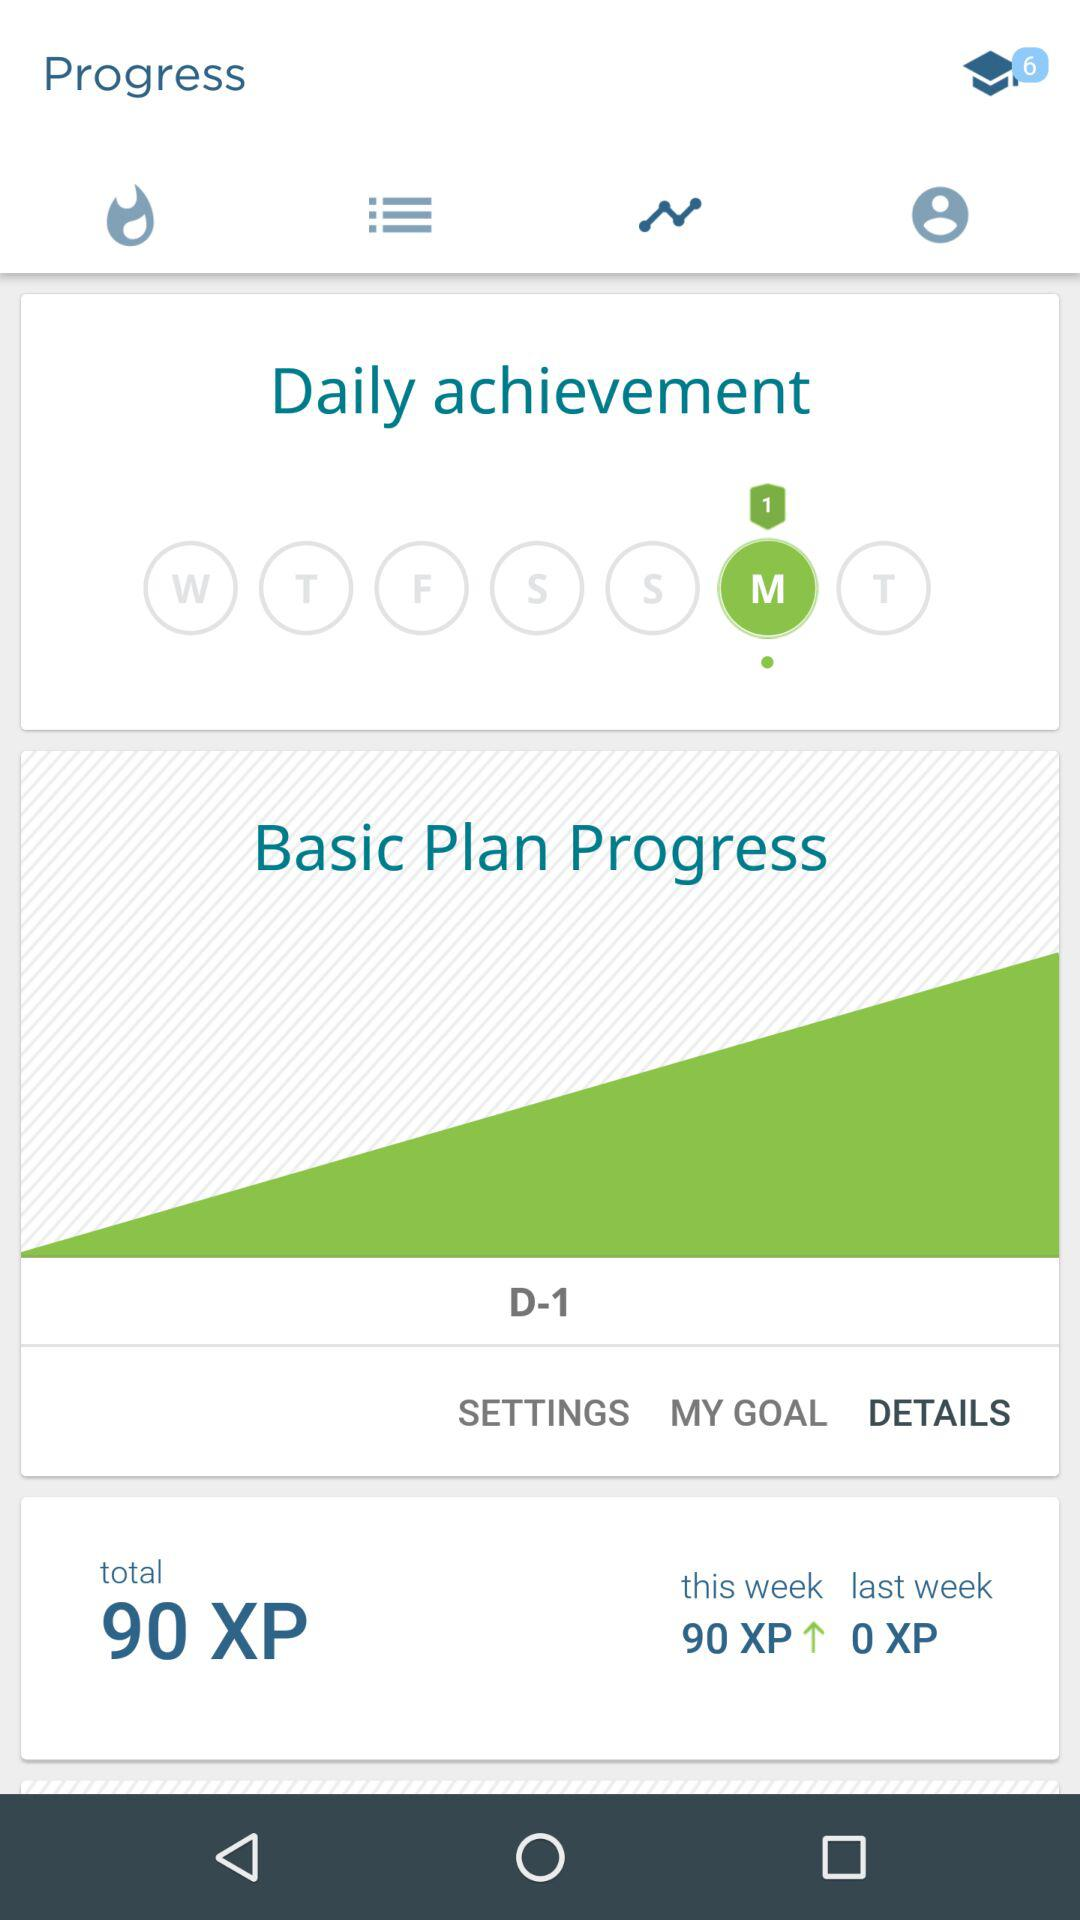How many more XP did I earn this week than last week?
Answer the question using a single word or phrase. 90 